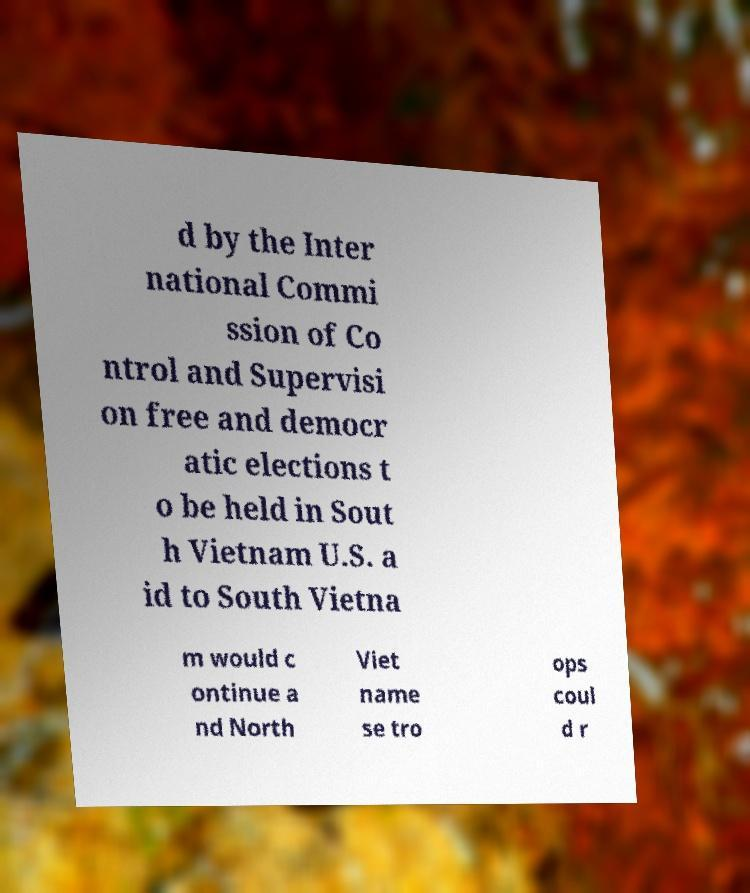Could you extract and type out the text from this image? d by the Inter national Commi ssion of Co ntrol and Supervisi on free and democr atic elections t o be held in Sout h Vietnam U.S. a id to South Vietna m would c ontinue a nd North Viet name se tro ops coul d r 